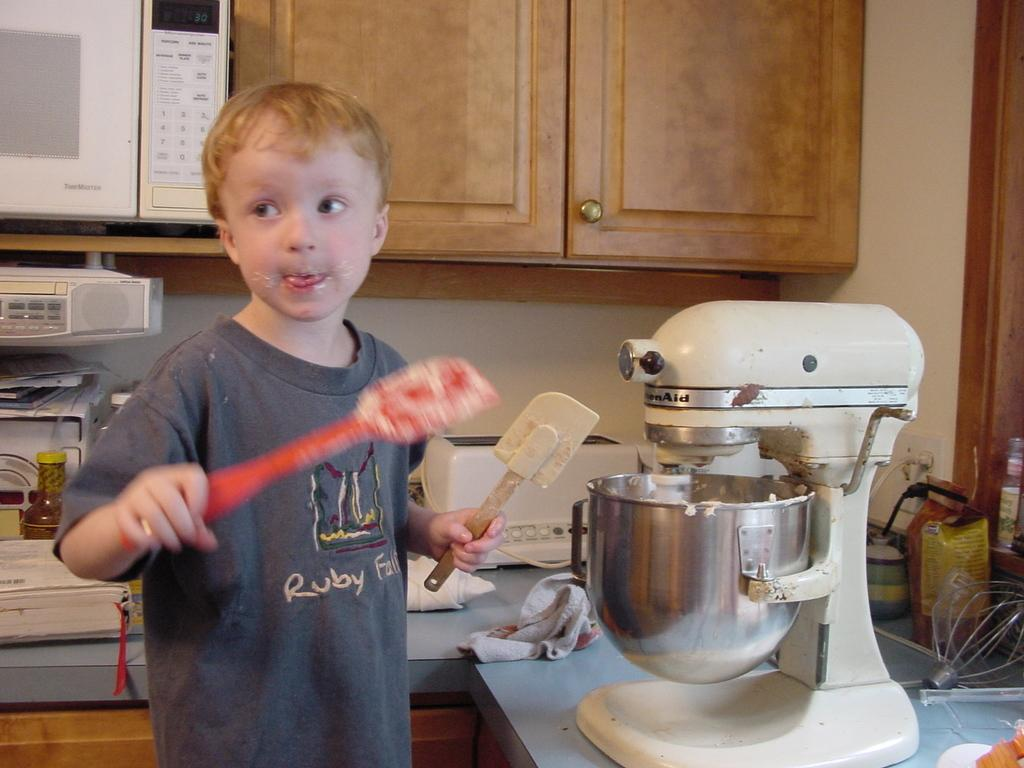<image>
Share a concise interpretation of the image provided. the word ruby is on the shirt of the person 